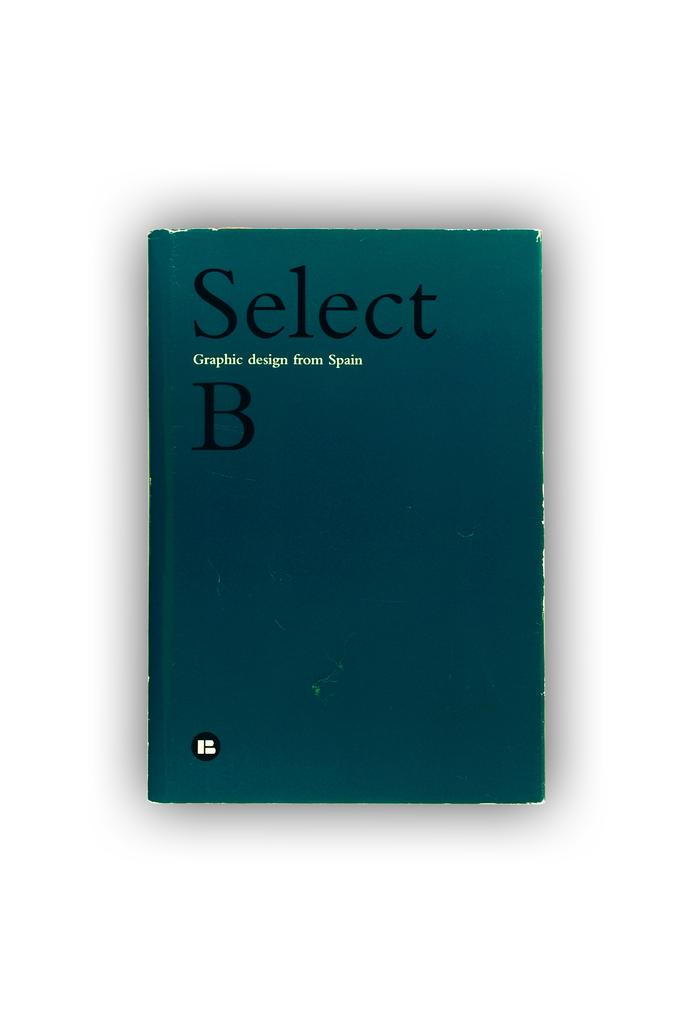<image>
Share a concise interpretation of the image provided. A blue book with black writing reading Select B on the cover. 